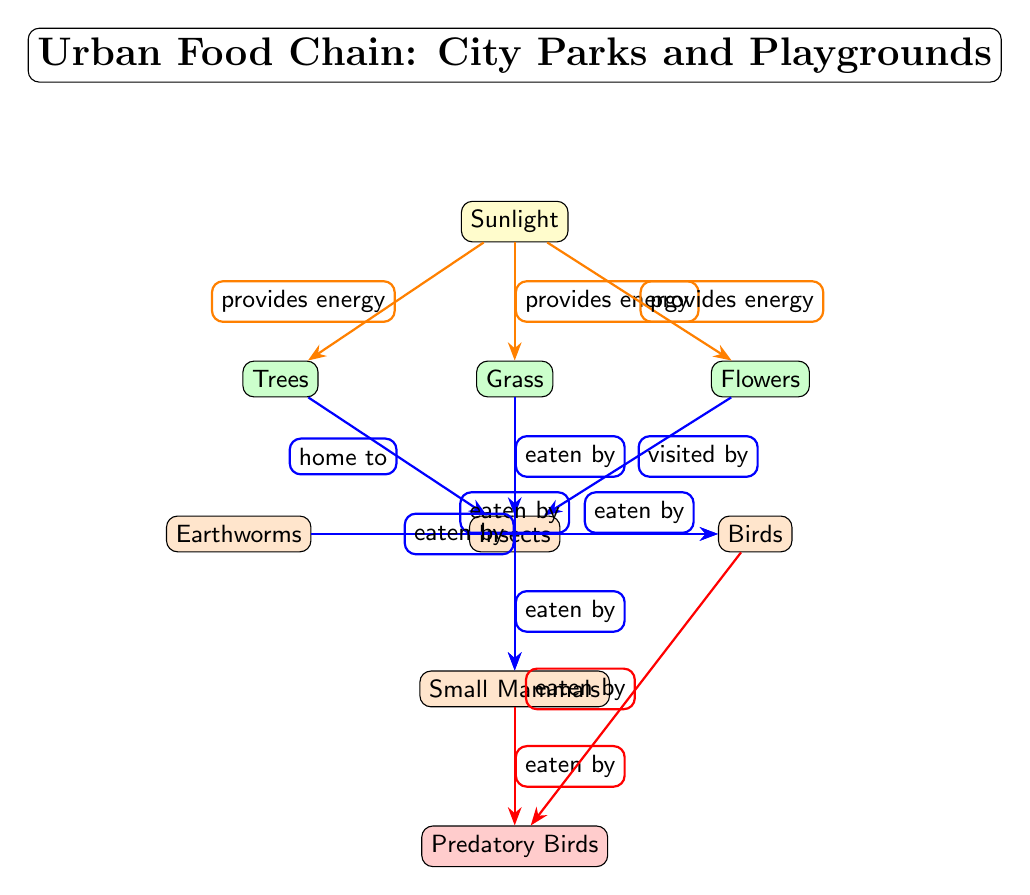What is the top node in the food chain? The highest node in the diagram represents the apex of the food chain, which is the predatory birds.
Answer: Predatory Birds How many producers are in the diagram? By counting the nodes labeled as producers, we find three: grass, trees, and flowers.
Answer: 3 What energy source is indicated at the top of the diagram? The sunlight node at the top provides energy to the producers below it.
Answer: Sunlight Which consumer is eaten by both small mammals and birds? The insects node is a shared prey for both small mammals and birds as indicated by the directed arrows.
Answer: Insects What do flowers provide to insects? The flow from flowers to insects indicates that flowers are visited by insects, providing a beneficial interaction.
Answer: Visited by What is the relationship between earthworms and birds? The diagram shows that earthworms are eaten by birds, which is a crucial interaction in the food chain.
Answer: Eaten by Which node has the most direct interactions with other nodes? The insects node interacts with multiple other nodes, both producers and consumers, thus playing a central role in the food web.
Answer: Insects How many apex consumers are present? The diagram only shows one apex consumer, which is the predatory birds at the end of the chain.
Answer: 1 What do small mammals eat according to the diagram? The arrows indicate that small mammals eat both grass and insects, representing their prey in the environment.
Answer: Grass and Insects 